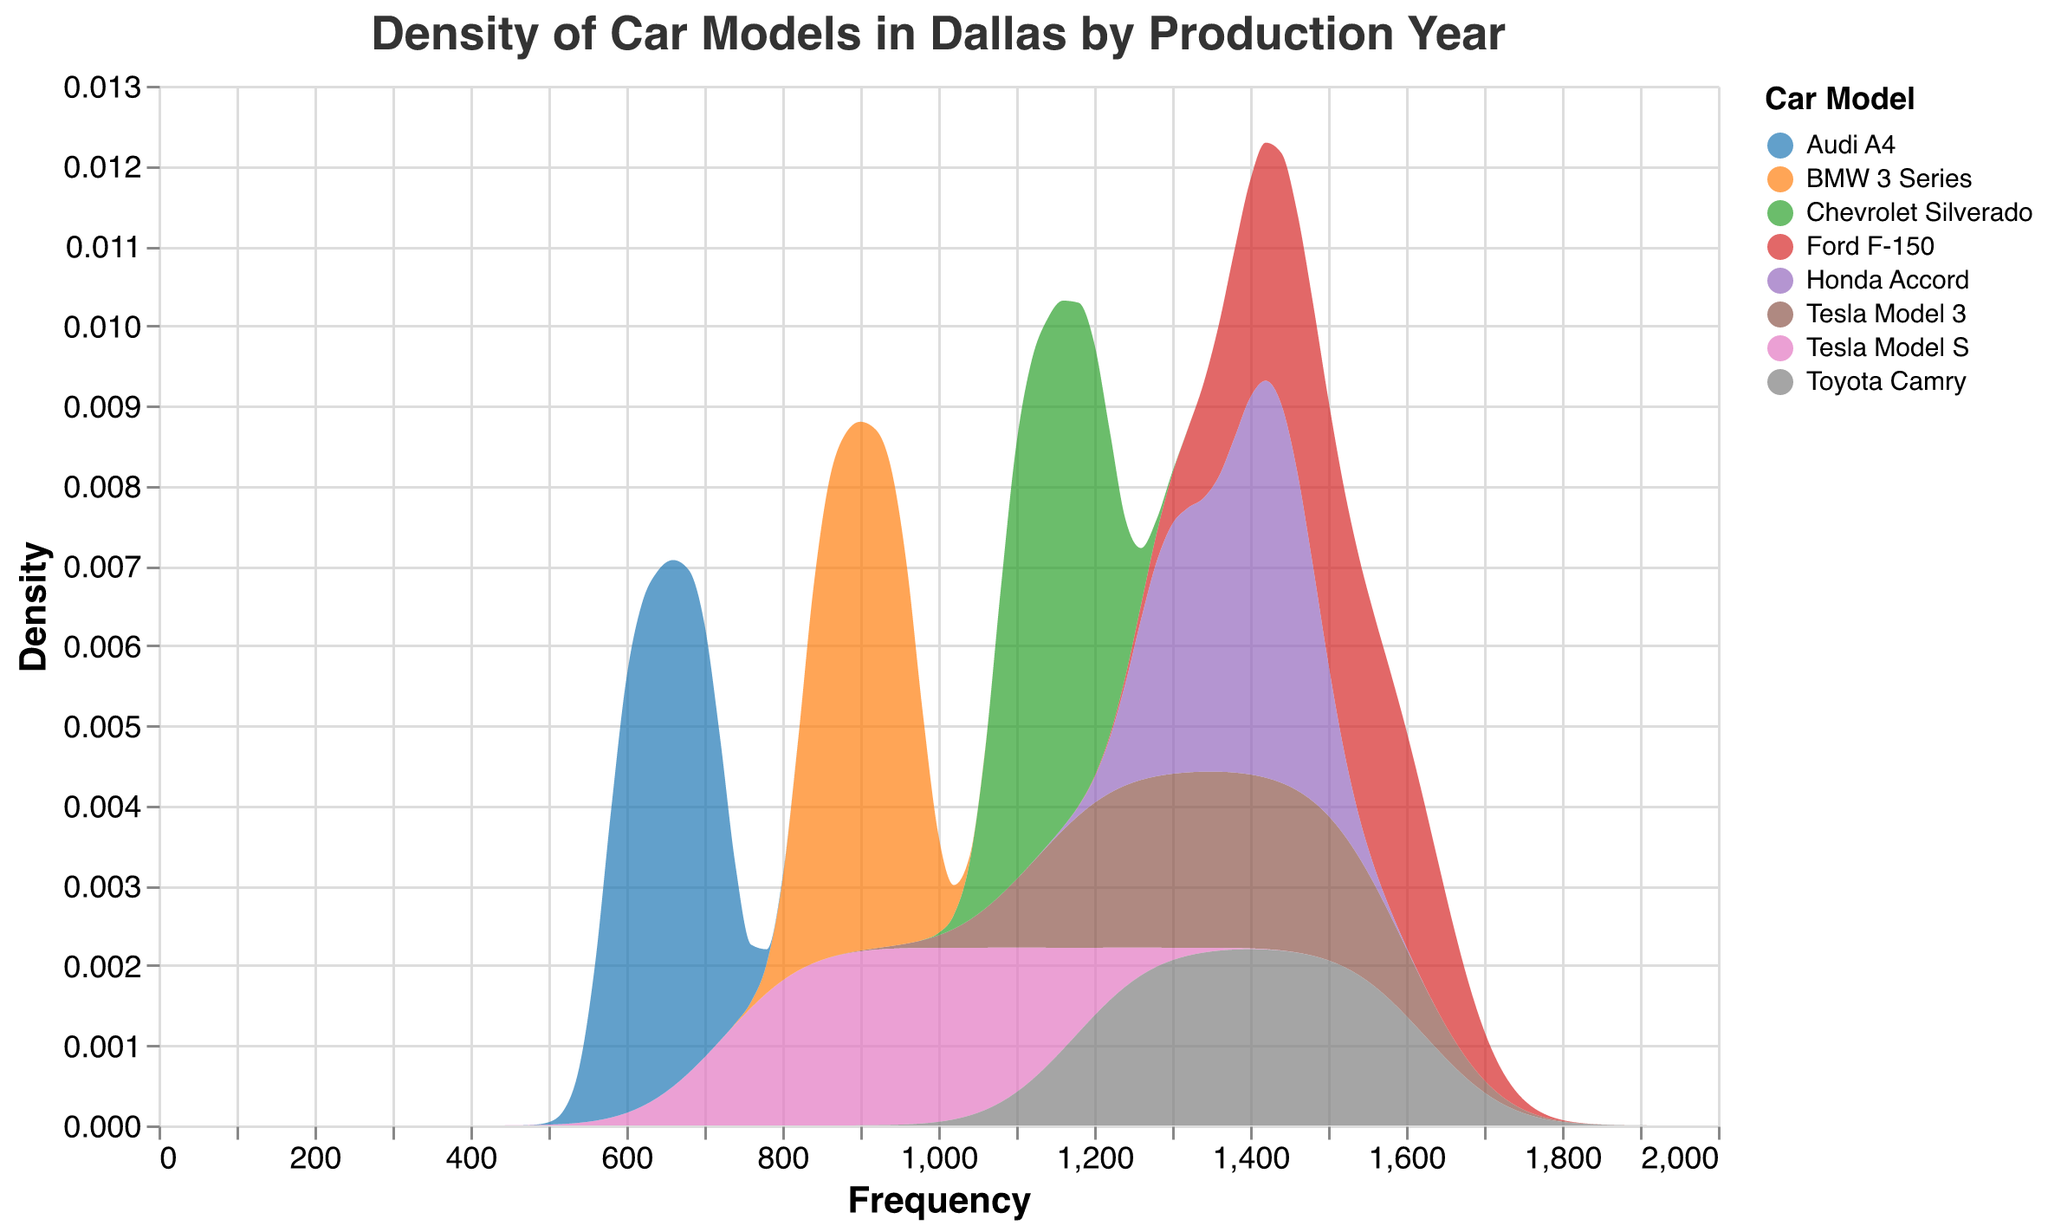What is the title of the plot? The title of the plot is usually located at the top of the figure and provides a summary of what the figure is displaying.
Answer: Density of Car Models in Dallas by Production Year How many car models are represented in the plot? The legend typically lists all the car models depicted in the plot, each with a different color.
Answer: 7 Which car model has the highest frequency in 2018? Look for the highest point on the plot for the year 2018 and identify the corresponding car model using the color legend.
Answer: Ford F-150 How does the density of Tesla Model 3 change from 2018 to 2020? Identify the Tesla Model 3 line and observe the density values from 2018 to 2020. Check if it increases, decreases, or stays the same.
Answer: It increases Which car model has the lowest density in 2017? Find the density values for all car models in 2017 and identify the lowest one using the y-axis values.
Answer: Audi A4 Compare the density of Honda Accord and Toyota Camry in 2016. Which one is higher? Locate the lines for Honda Accord and Toyota Camry in 2016 and compare their density values.
Answer: Honda Accord In 2019, how do the densities of Tesla Model S and BMW 3 Series compare? Locate the densities of Tesla Model S and BMW 3 Series for the year 2019 and compare them.
Answer: Tesla Model S is higher What is the approximate density range for Chevrolet Silverado in 2015? Find the range of density values the Chevrolet Silverado spans along the y-axis for the year 2015.
Answer: 0 to 1 Among all car models, which one shows a consistent increase in density from 2015 to 2020? Identify the trend lines for all car models and check which one consistently increases in density over the given years.
Answer: Tesla Model 3 Which car models have overlapping densities in the year 2018? Observe the 2018 densities for all lines and identify where two or more car models' lines overlap.
Answer: Toyota Camry and Ford F-150 